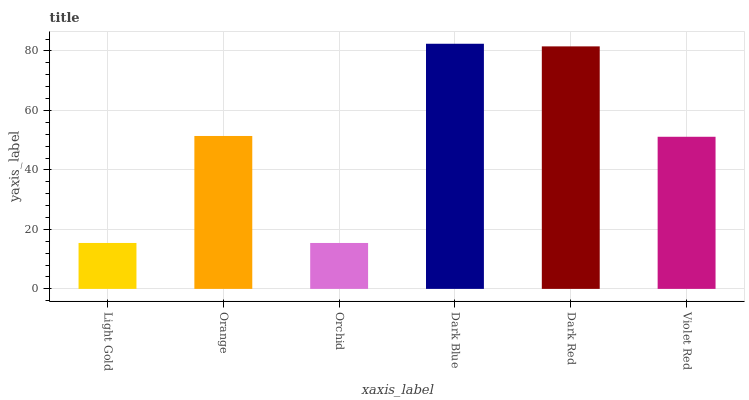Is Orchid the minimum?
Answer yes or no. Yes. Is Dark Blue the maximum?
Answer yes or no. Yes. Is Orange the minimum?
Answer yes or no. No. Is Orange the maximum?
Answer yes or no. No. Is Orange greater than Light Gold?
Answer yes or no. Yes. Is Light Gold less than Orange?
Answer yes or no. Yes. Is Light Gold greater than Orange?
Answer yes or no. No. Is Orange less than Light Gold?
Answer yes or no. No. Is Orange the high median?
Answer yes or no. Yes. Is Violet Red the low median?
Answer yes or no. Yes. Is Dark Blue the high median?
Answer yes or no. No. Is Light Gold the low median?
Answer yes or no. No. 